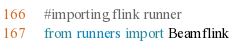<code> <loc_0><loc_0><loc_500><loc_500><_Python_>#importing flink runner 
from runners import Beamflink
</code> 